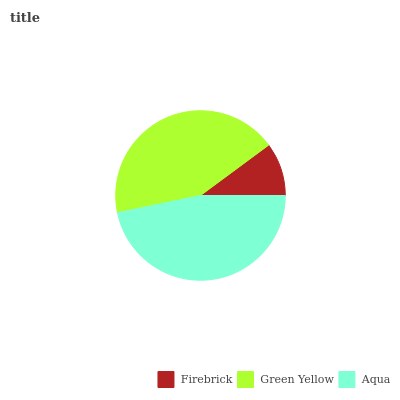Is Firebrick the minimum?
Answer yes or no. Yes. Is Aqua the maximum?
Answer yes or no. Yes. Is Green Yellow the minimum?
Answer yes or no. No. Is Green Yellow the maximum?
Answer yes or no. No. Is Green Yellow greater than Firebrick?
Answer yes or no. Yes. Is Firebrick less than Green Yellow?
Answer yes or no. Yes. Is Firebrick greater than Green Yellow?
Answer yes or no. No. Is Green Yellow less than Firebrick?
Answer yes or no. No. Is Green Yellow the high median?
Answer yes or no. Yes. Is Green Yellow the low median?
Answer yes or no. Yes. Is Aqua the high median?
Answer yes or no. No. Is Aqua the low median?
Answer yes or no. No. 